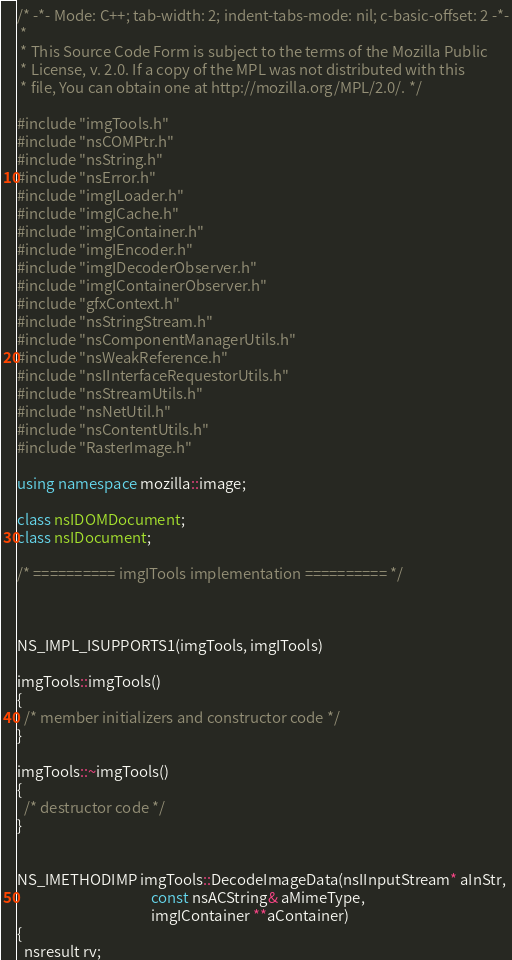<code> <loc_0><loc_0><loc_500><loc_500><_C++_>/* -*- Mode: C++; tab-width: 2; indent-tabs-mode: nil; c-basic-offset: 2 -*-
 *
 * This Source Code Form is subject to the terms of the Mozilla Public
 * License, v. 2.0. If a copy of the MPL was not distributed with this
 * file, You can obtain one at http://mozilla.org/MPL/2.0/. */

#include "imgTools.h"
#include "nsCOMPtr.h"
#include "nsString.h"
#include "nsError.h"
#include "imgILoader.h"
#include "imgICache.h"
#include "imgIContainer.h"
#include "imgIEncoder.h"
#include "imgIDecoderObserver.h"
#include "imgIContainerObserver.h"
#include "gfxContext.h"
#include "nsStringStream.h"
#include "nsComponentManagerUtils.h"
#include "nsWeakReference.h"
#include "nsIInterfaceRequestorUtils.h"
#include "nsStreamUtils.h"
#include "nsNetUtil.h"
#include "nsContentUtils.h"
#include "RasterImage.h"

using namespace mozilla::image;

class nsIDOMDocument;
class nsIDocument;

/* ========== imgITools implementation ========== */



NS_IMPL_ISUPPORTS1(imgTools, imgITools)

imgTools::imgTools()
{
  /* member initializers and constructor code */
}

imgTools::~imgTools()
{
  /* destructor code */
}


NS_IMETHODIMP imgTools::DecodeImageData(nsIInputStream* aInStr,
                                        const nsACString& aMimeType,
                                        imgIContainer **aContainer)
{
  nsresult rv;</code> 